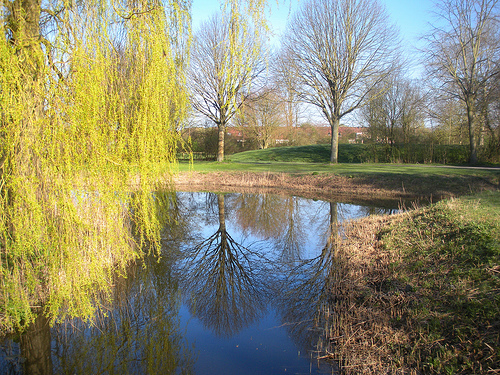<image>
Can you confirm if the tree is behind the wall? No. The tree is not behind the wall. From this viewpoint, the tree appears to be positioned elsewhere in the scene. 